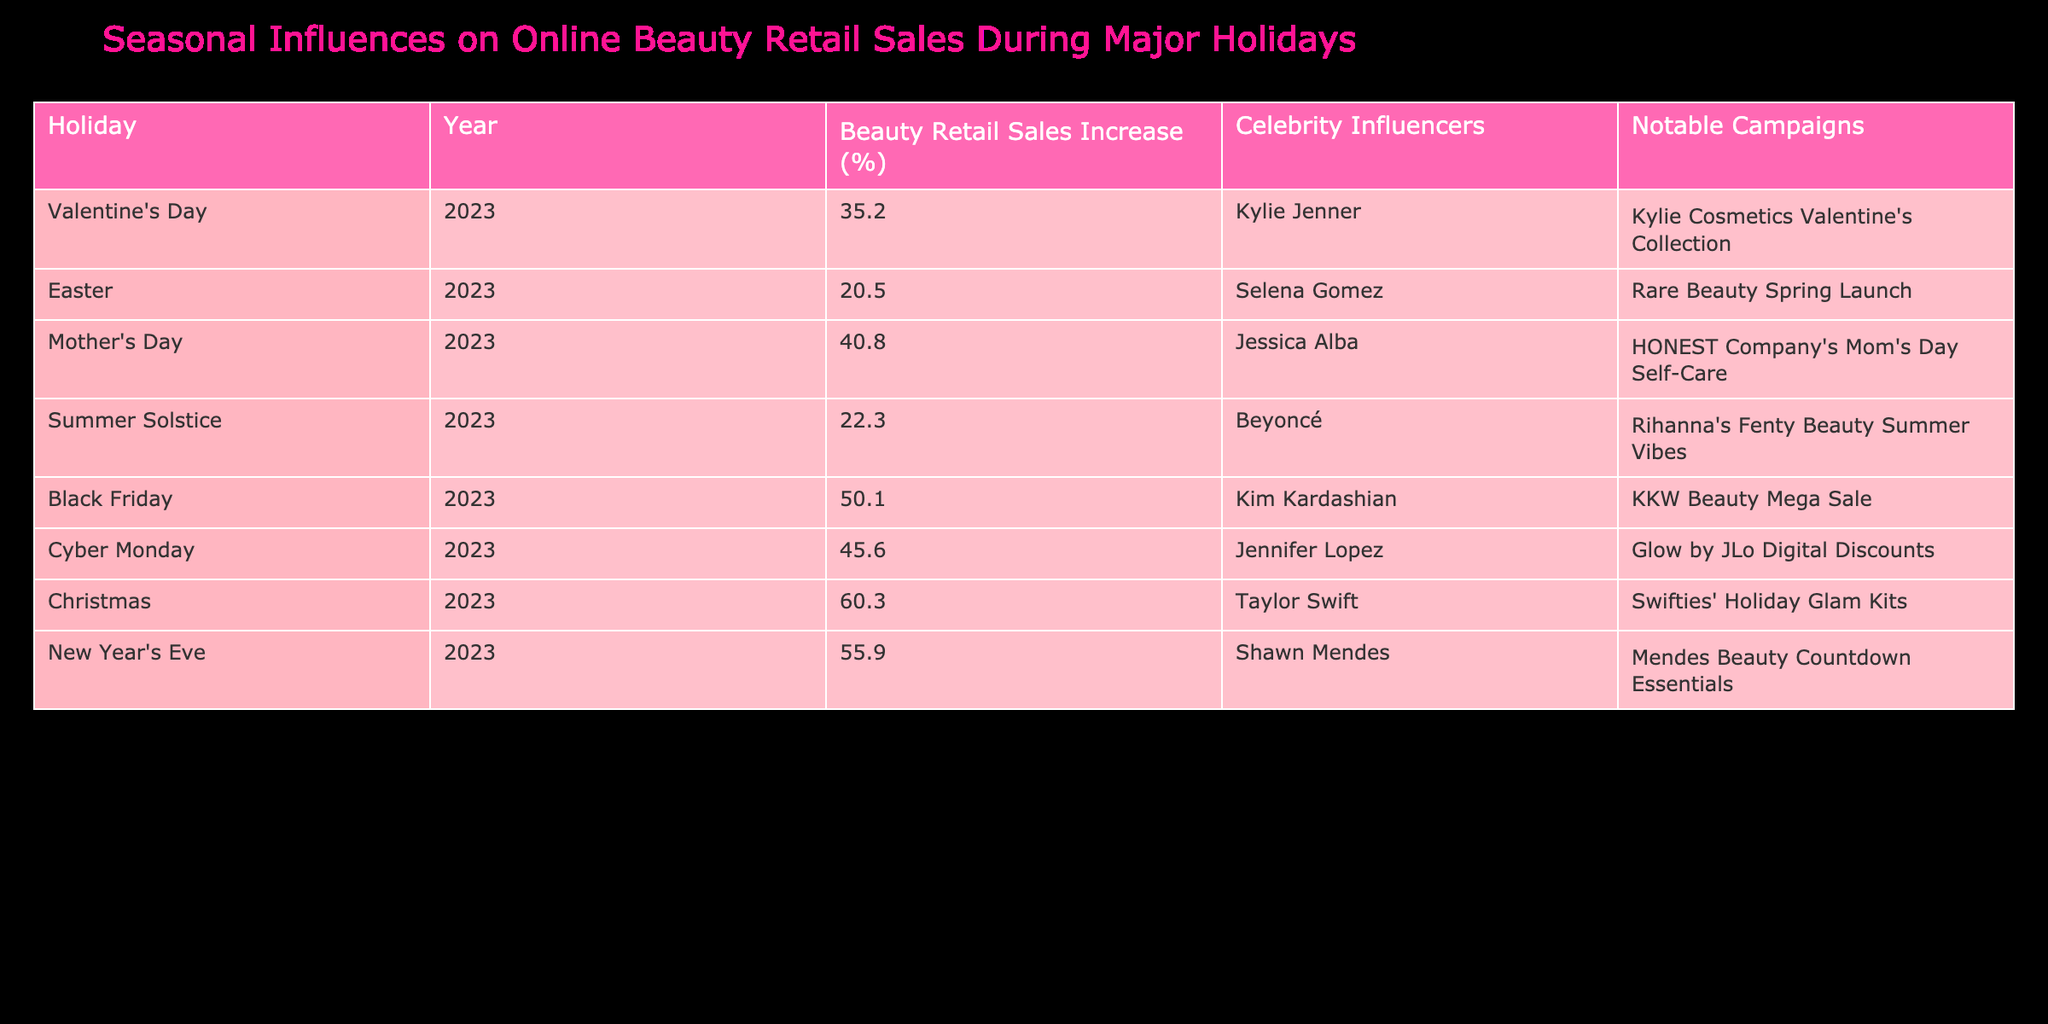What holiday had the highest beauty retail sales increase in 2023? The table lists the percentage increase for each holiday, and Christmas shows an increase of 60.3%, which is the highest value compared to the others.
Answer: Christmas Which celebrity influencer was associated with the Mother's Day campaign? The table indicates that Jessica Alba was the celebrity influencer for Mother's Day in 2023.
Answer: Jessica Alba What is the average beauty retail sales increase for all the holidays listed? To find the average, sum the sales increases: (35.2 + 20.5 + 40.8 + 22.3 + 50.1 + 45.6 + 60.3 + 55.9) = 330.7. Then divide by the number of holidays, which is 8: 330.7 / 8 = 41.34.
Answer: 41.34 Did Selena Gomez have the highest sales percentage increase among the celebrity influencers listed? By comparing the sales increases, Selena Gomez’s percentage for Easter is 20.5%, which is lower than several others including Taylor Swift at 60.3%. Thus, the statement is false.
Answer: No Which campaign had the second-highest beauty retail sales increase during the holidays? Observing the sales percentages, Black Friday with 50.1% is the second highest after Christmas at 60.3%.
Answer: Black Friday 